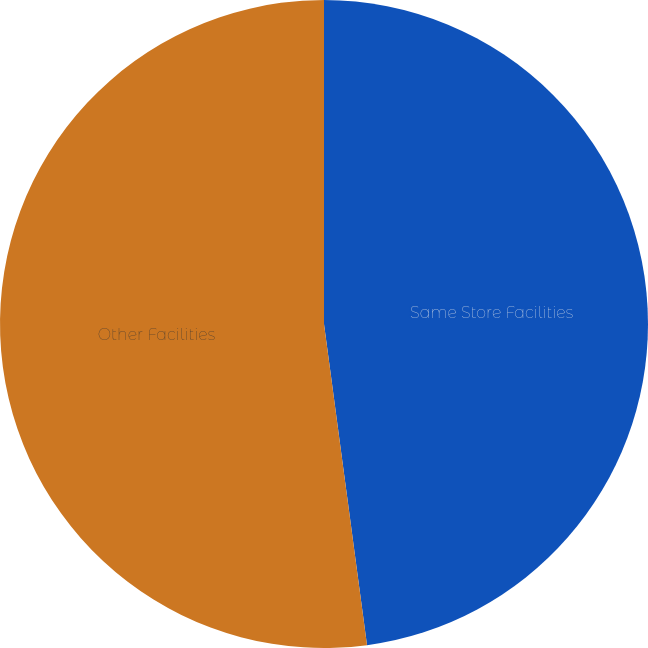Convert chart to OTSL. <chart><loc_0><loc_0><loc_500><loc_500><pie_chart><fcel>Same Store Facilities<fcel>Other Facilities<nl><fcel>47.88%<fcel>52.12%<nl></chart> 